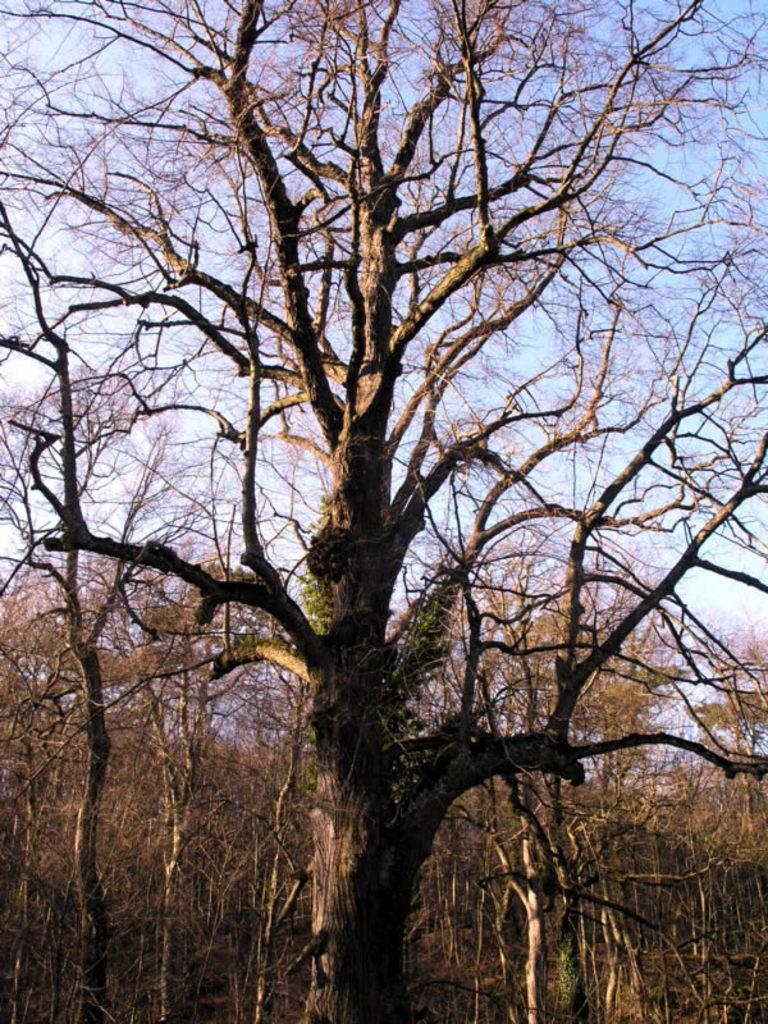What type of trees are visible in the image? There are bare trees in the image. What is visible in the background of the image? There is sky visible in the background of the image. What type of stew is being prepared in the image? There is no stew present in the image; it features bare trees and sky. What type of fold is visible in the image? There is no fold present in the image. 